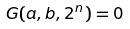<formula> <loc_0><loc_0><loc_500><loc_500>G ( a , b , 2 ^ { n } ) = 0</formula> 